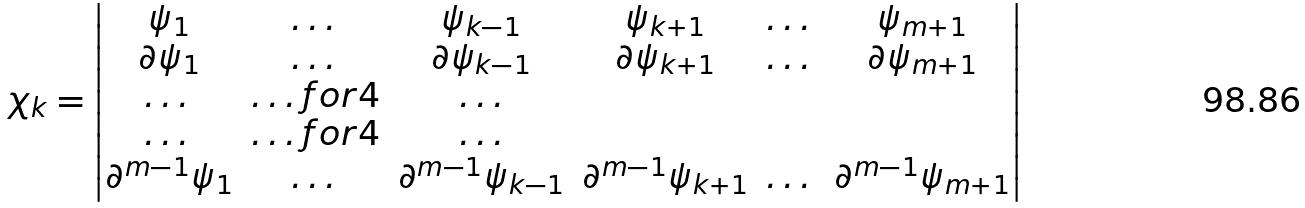<formula> <loc_0><loc_0><loc_500><loc_500>\chi _ { k } = \begin{vmatrix} \psi _ { 1 } & \dots & \psi _ { k - 1 } & \psi _ { k + 1 } & \dots & \psi _ { m + 1 } \\ \partial \psi _ { 1 } & \dots & \partial \psi _ { k - 1 } & \partial \psi _ { k + 1 } & \dots & \partial \psi _ { m + 1 } \\ \dots & \hdots f o r { 4 } & \dots \\ \dots & \hdots f o r { 4 } & \dots \\ \partial ^ { m - 1 } \psi _ { 1 } & \dots & \partial ^ { m - 1 } \psi _ { k - 1 } & \partial ^ { m - 1 } \psi _ { k + 1 } & \dots & \partial ^ { m - 1 } \psi _ { m + 1 } \end{vmatrix}</formula> 